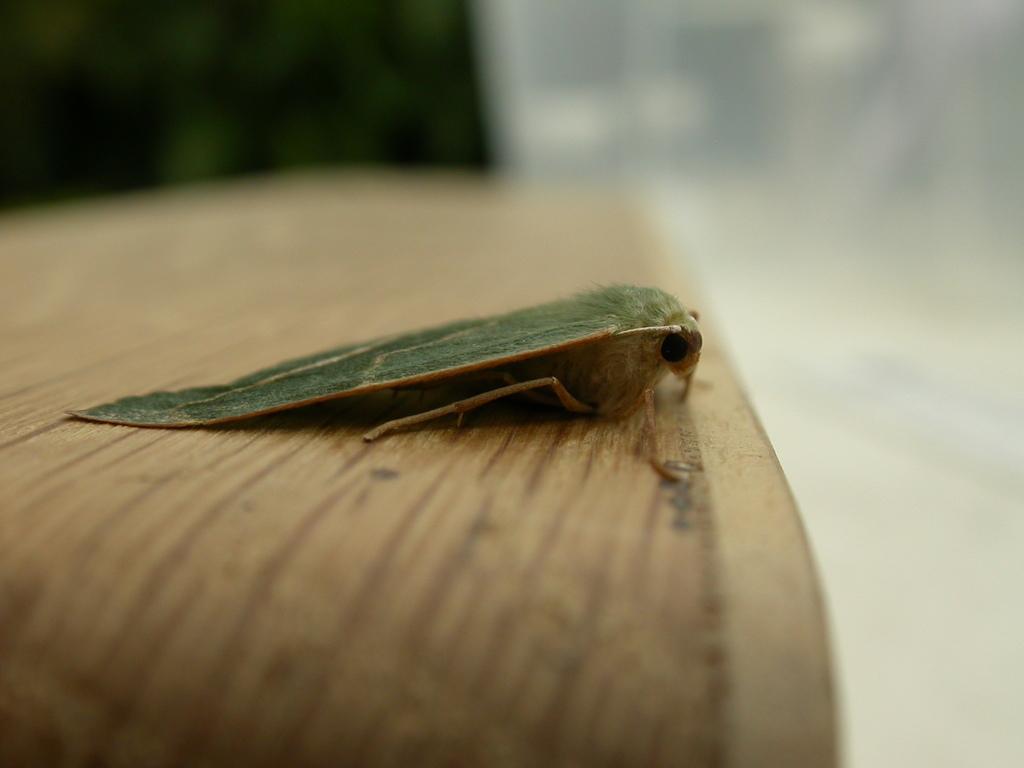Describe this image in one or two sentences. In this picture there is an insect on the table. On the right side of the image, image is blurry and the insect is in green and in cream color. 